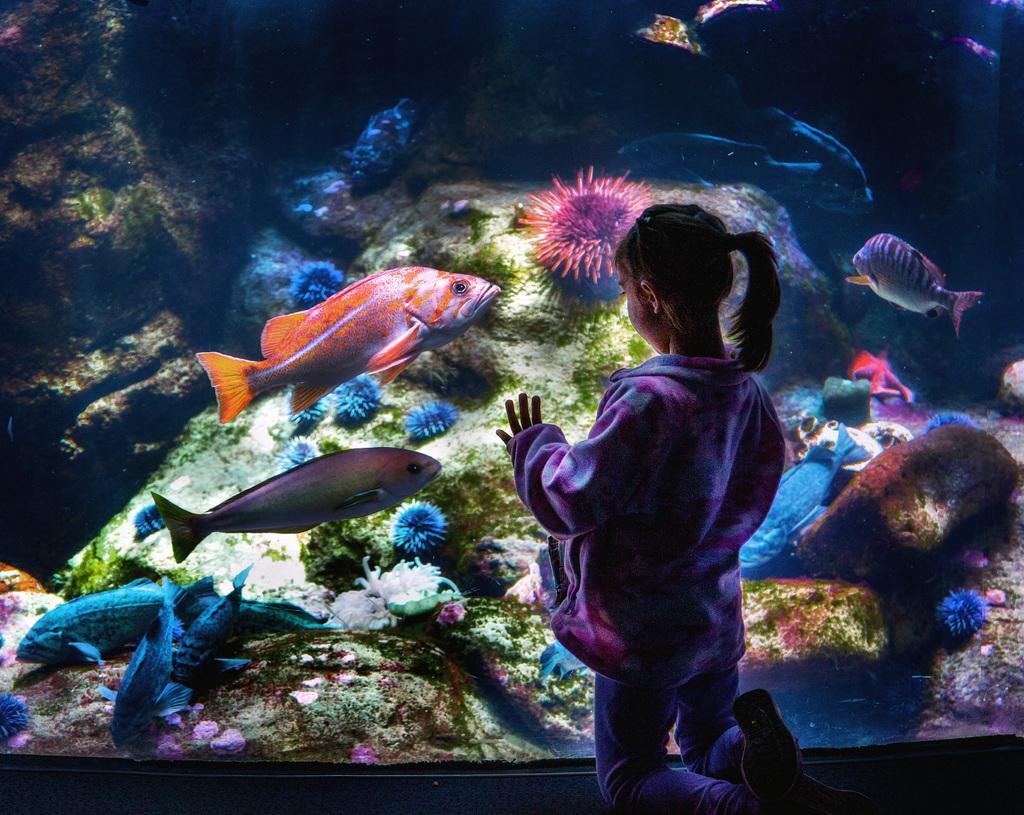Please provide a concise description of this image. This image consists of a girl standing near the aquarium. In which there are fishes and plants. In the background, its looks like a rock. 